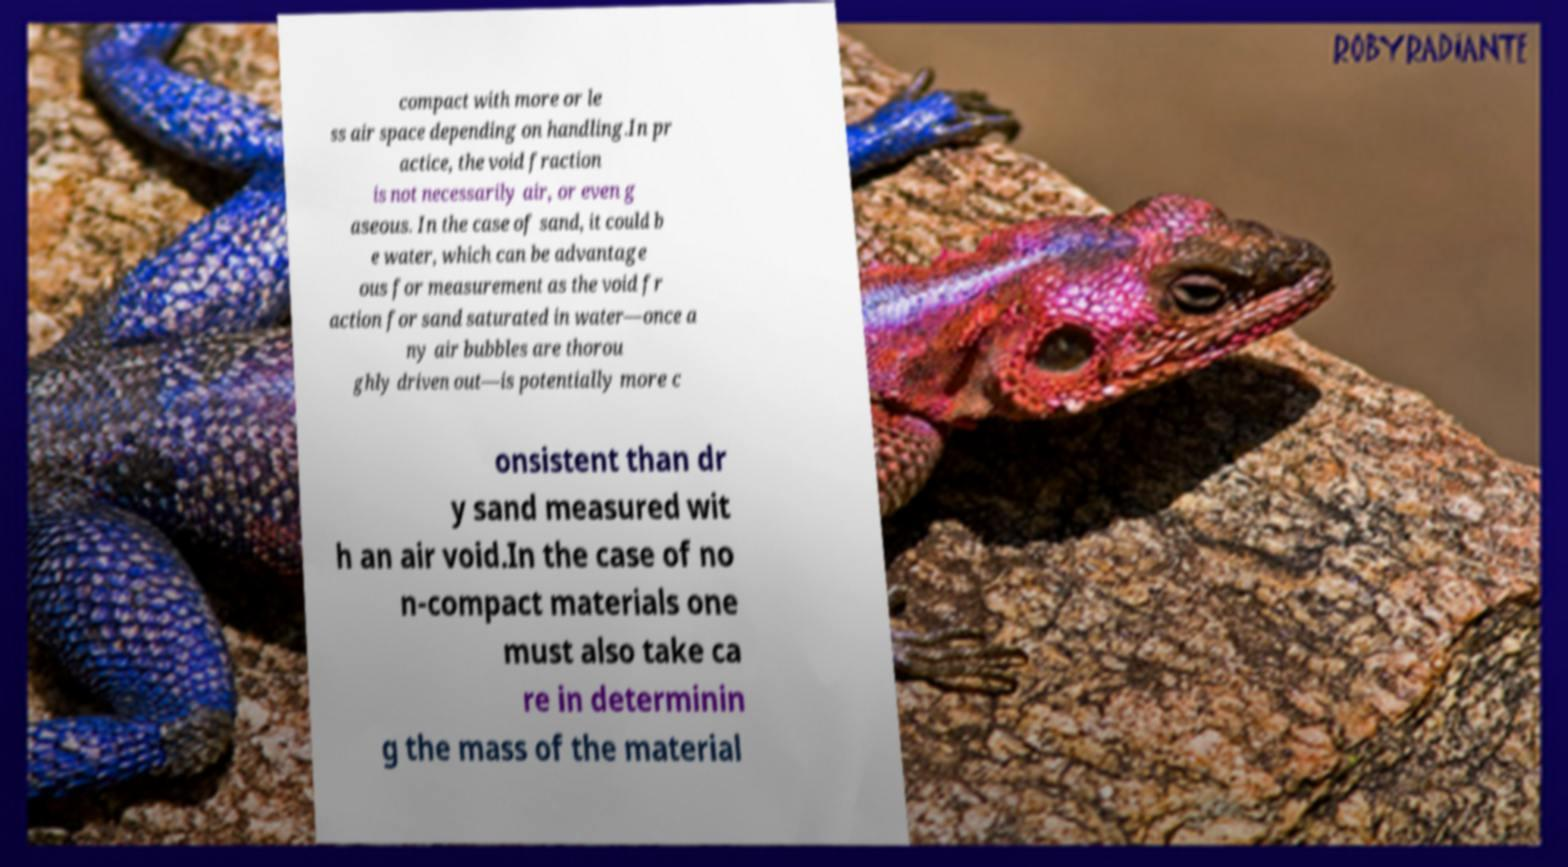Please identify and transcribe the text found in this image. compact with more or le ss air space depending on handling.In pr actice, the void fraction is not necessarily air, or even g aseous. In the case of sand, it could b e water, which can be advantage ous for measurement as the void fr action for sand saturated in water—once a ny air bubbles are thorou ghly driven out—is potentially more c onsistent than dr y sand measured wit h an air void.In the case of no n-compact materials one must also take ca re in determinin g the mass of the material 